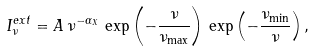Convert formula to latex. <formula><loc_0><loc_0><loc_500><loc_500>I _ { \nu } ^ { e x t } = A \, \nu ^ { - \alpha _ { X } } \, \exp \left ( - \frac { \nu } { \nu _ { \max } } \right ) \, \exp \left ( - \frac { \nu _ { \min } } { \nu } \right ) ,</formula> 